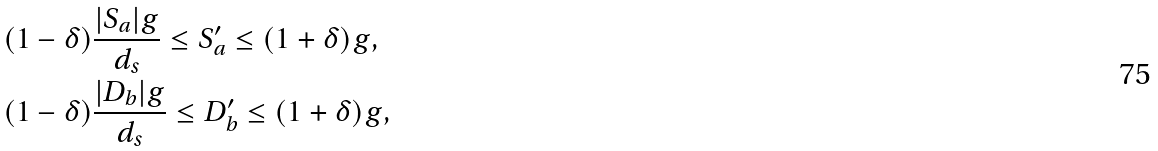Convert formula to latex. <formula><loc_0><loc_0><loc_500><loc_500>& ( 1 - \delta ) \frac { | S _ { a } | g } { d _ { s } } \leq S ^ { \prime } _ { a } \leq ( 1 + \delta ) g , \\ & ( 1 - \delta ) \frac { | D _ { b } | g } { d _ { s } } \leq D ^ { \prime } _ { b } \leq ( 1 + \delta ) g ,</formula> 